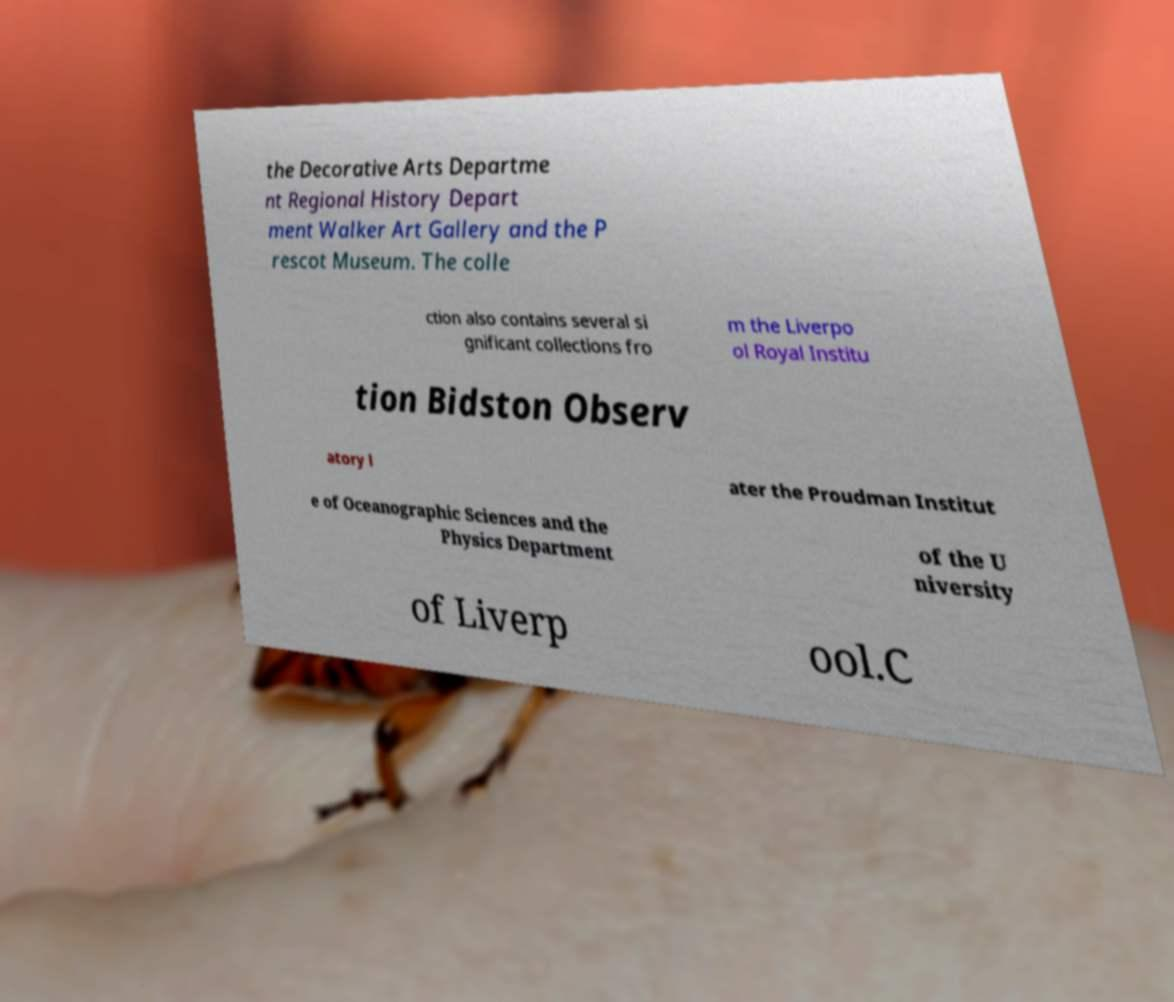Please read and relay the text visible in this image. What does it say? the Decorative Arts Departme nt Regional History Depart ment Walker Art Gallery and the P rescot Museum. The colle ction also contains several si gnificant collections fro m the Liverpo ol Royal Institu tion Bidston Observ atory l ater the Proudman Institut e of Oceanographic Sciences and the Physics Department of the U niversity of Liverp ool.C 